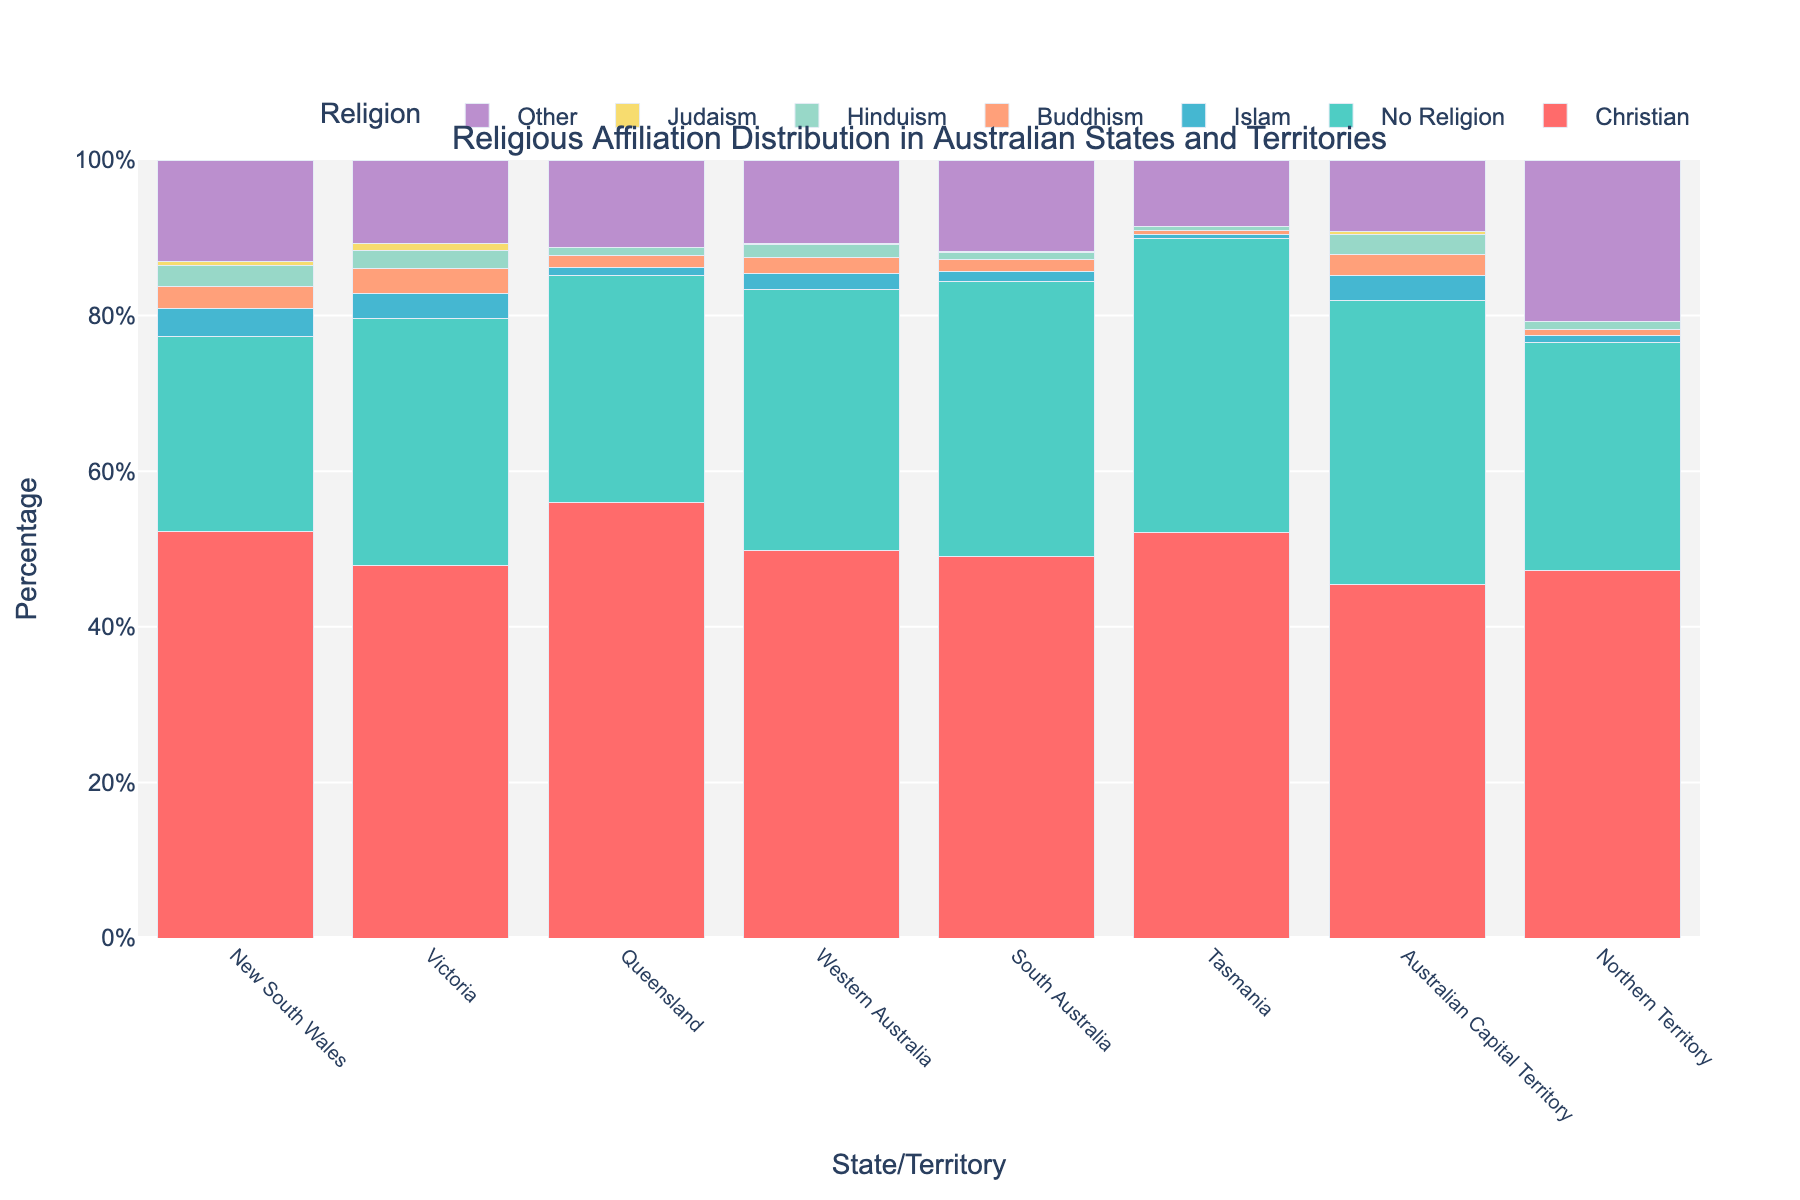Which state has the highest percentage of people with no religion? To determine this, examine the height of the bar representing "No Religion" for each state. The highest bar is in Tasmania.
Answer: Tasmania How many states/territories have a higher percentage of Christians compared to people with no religion? Compare the percentage bars for "Christian" and "No Religion" in each state/territory. The states/territories where "Christian" is higher are New South Wales, Queensland, Tasmania, and Northern Territory.
Answer: 4 Which state has the lowest percentage of people who follow Hinduism? Look for the bar representing "Hinduism" in each state and find the shortest one. The shortest bar is in Tasmania.
Answer: Tasmania What is the combined percentage of Buddhists and Hindus in Victoria? Add the percentages for "Buddhism" and "Hinduism" in Victoria. Buddhism is 3.2% and Hinduism is 2.3%, so the sum is 3.2% + 2.3% = 5.5%.
Answer: 5.5% In which state is the percentage of people identifying as Jewish the highest relative to other states? Identify the highest bar for "Judaism" across states. The tallest bar is in Victoria with 0.9%.
Answer: Victoria Which state has the closest percentage values between Islam and Buddhism? Compare the height of the bars for "Islam" and "Buddhism" in each state to find the smallest difference. The smallest difference is in South Australia, where Islam is 1.3% and Buddhism is 1.5%, which gives a difference of 0.2%.
Answer: South Australia What is the percentage range of Christians across all states and territories? Identify the maximum and minimum percentages for "Christian". The highest is in Queensland at 56.0% and the lowest in the Australian Capital Territory at 45.4%, so the range is 56.0% - 45.4% = 10.6%.
Answer: 10.6% Which state/territory has the highest percentage of people with other religions (excluding the main listed ones)? Find the tallest bar representing "Other" religions. The tallest bar is in Northern Territory with 20.7%.
Answer: Northern Territory What's the average percentage of Christians across all states and territories? Sum the percentages for "Christian" in all states, then divide by the number of states/territories. (52.2 + 47.9 + 56.0 + 49.8 + 49.0 + 52.1 + 45.4 + 47.2) / 8 = 50.0%.
Answer: 50.0% Compare the percentage of people with no religion between New South Wales and Victoria. Which is higher and by how much? Subtract the percentage of "No Religion" in New South Wales from that in Victoria: 31.7% - 25.1% = 6.6%. Victoria has a higher percentage by 6.6%.
Answer: Victoria, 6.6% 